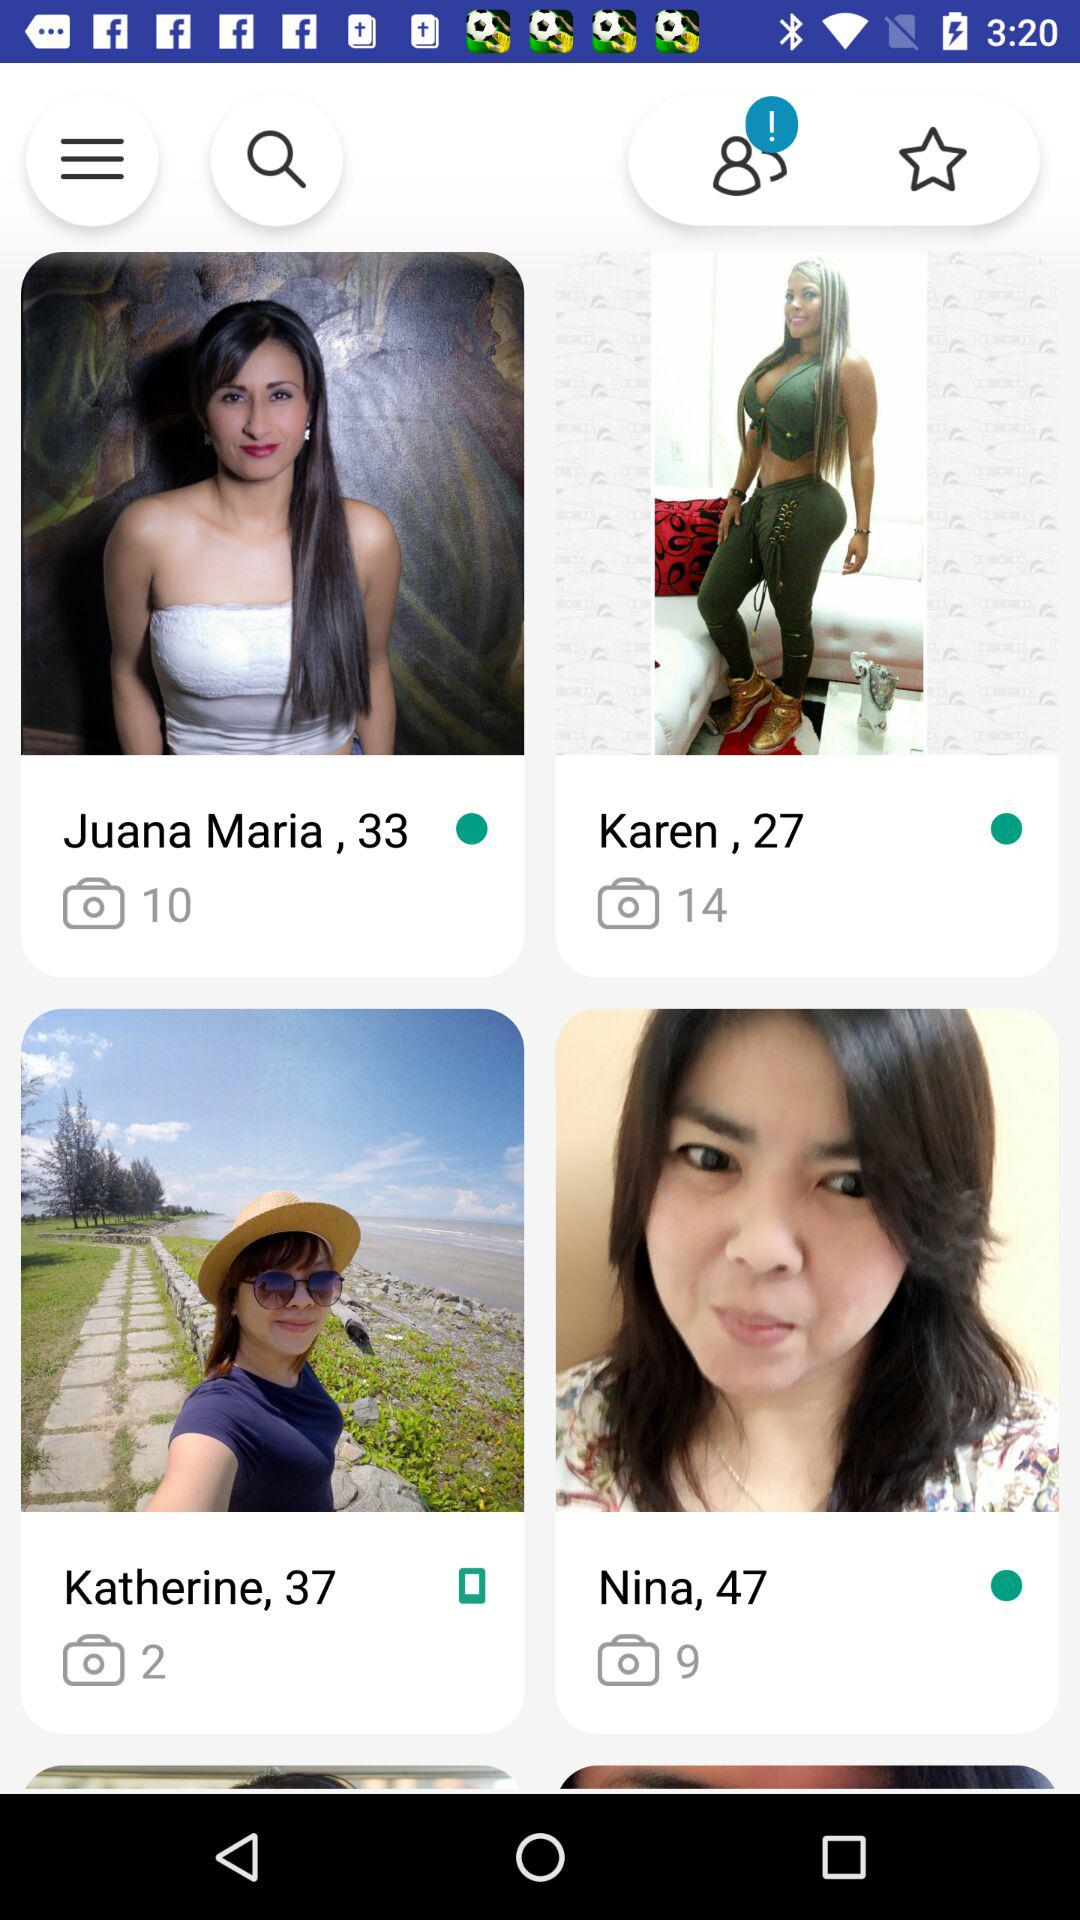Which person took more photos, Nina or Katherine?
Answer the question using a single word or phrase. Nina 